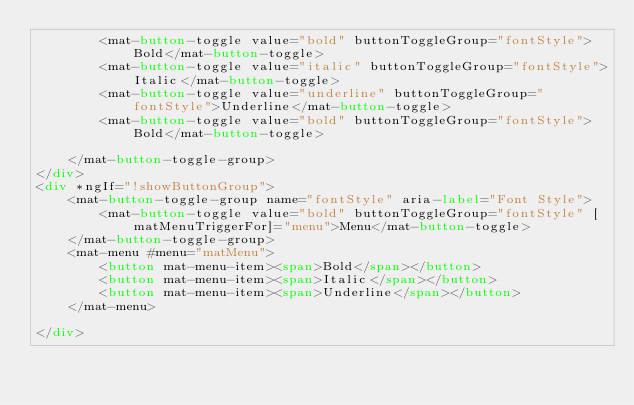<code> <loc_0><loc_0><loc_500><loc_500><_HTML_>		<mat-button-toggle value="bold" buttonToggleGroup="fontStyle">Bold</mat-button-toggle>
		<mat-button-toggle value="italic" buttonToggleGroup="fontStyle">Italic</mat-button-toggle>
		<mat-button-toggle value="underline" buttonToggleGroup="fontStyle">Underline</mat-button-toggle>
		<mat-button-toggle value="bold" buttonToggleGroup="fontStyle">Bold</mat-button-toggle>

	</mat-button-toggle-group>
</div>
<div *ngIf="!showButtonGroup">
	<mat-button-toggle-group name="fontStyle" aria-label="Font Style">
		<mat-button-toggle value="bold" buttonToggleGroup="fontStyle" [matMenuTriggerFor]="menu">Menu</mat-button-toggle>
	</mat-button-toggle-group>
	<mat-menu #menu="matMenu">
		<button mat-menu-item><span>Bold</span></button>
		<button mat-menu-item><span>Italic</span></button>
		<button mat-menu-item><span>Underline</span></button>
	</mat-menu>

</div></code> 